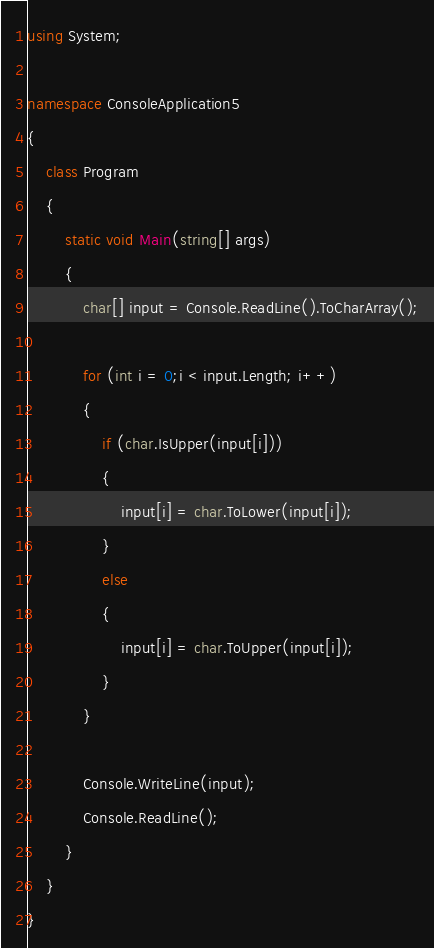<code> <loc_0><loc_0><loc_500><loc_500><_C#_>using System;

namespace ConsoleApplication5
{
    class Program
    {
        static void Main(string[] args)
        {
            char[] input = Console.ReadLine().ToCharArray();

            for (int i = 0;i < input.Length; i++)
            {
                if (char.IsUpper(input[i]))
                {
                    input[i] = char.ToLower(input[i]);
                }
                else
                {
                    input[i] = char.ToUpper(input[i]);
                }
            }

            Console.WriteLine(input);
            Console.ReadLine();
        }
    }
}</code> 